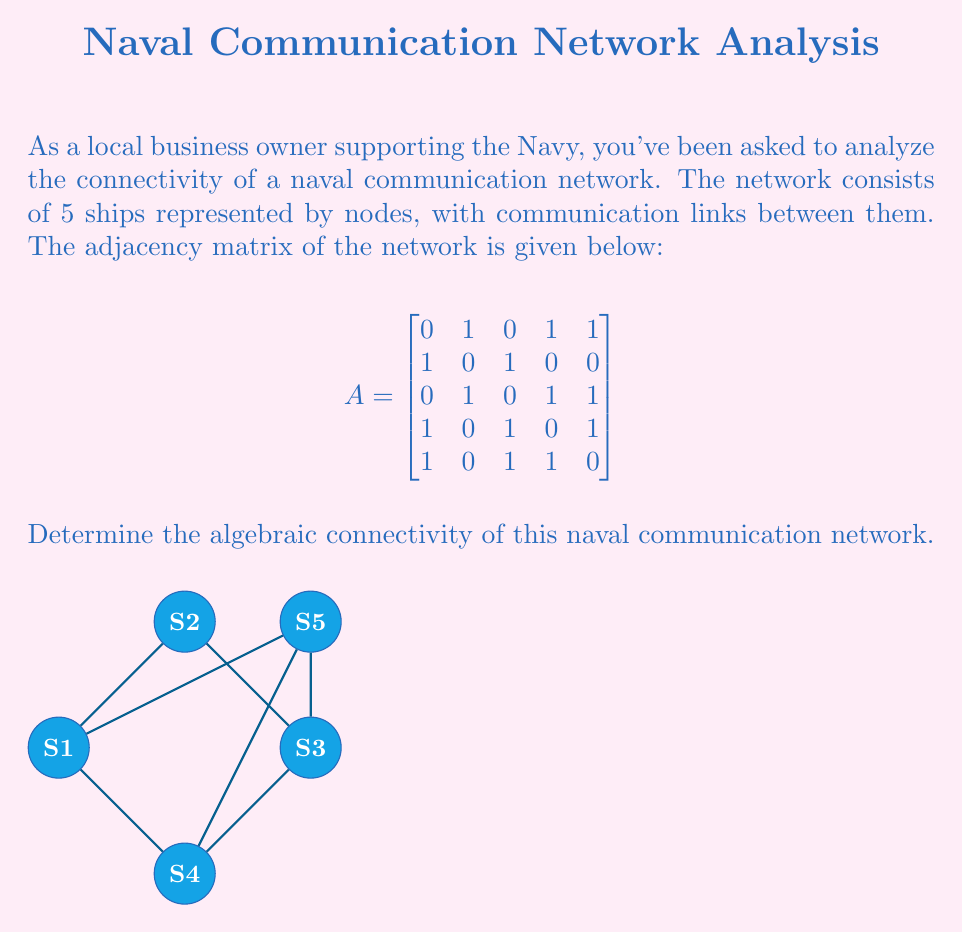Show me your answer to this math problem. To find the algebraic connectivity of the naval communication network, we need to follow these steps:

1) First, calculate the degree matrix $D$. The degree of each node is the sum of its row in the adjacency matrix:
   $$D = \begin{bmatrix}
   3 & 0 & 0 & 0 & 0 \\
   0 & 2 & 0 & 0 & 0 \\
   0 & 0 & 3 & 0 & 0 \\
   0 & 0 & 0 & 3 & 0 \\
   0 & 0 & 0 & 0 & 3
   \end{bmatrix}$$

2) Calculate the Laplacian matrix $L = D - A$:
   $$L = \begin{bmatrix}
   3 & -1 & 0 & -1 & -1 \\
   -1 & 2 & -1 & 0 & 0 \\
   0 & -1 & 3 & -1 & -1 \\
   -1 & 0 & -1 & 3 & -1 \\
   -1 & 0 & -1 & -1 & 3
   \end{bmatrix}$$

3) Find the eigenvalues of $L$. We can use a computer algebra system for this:
   $\lambda_1 = 0$
   $\lambda_2 \approx 0.7639$
   $\lambda_3 \approx 2.0000$
   $\lambda_4 \approx 3.2361$
   $\lambda_5 = 5$

4) The algebraic connectivity is the second smallest eigenvalue of $L$, which is $\lambda_2 \approx 0.7639$.

This value indicates how well-connected the network is. A higher value suggests better connectivity and robustness in the communication network.
Answer: $0.7639$ 